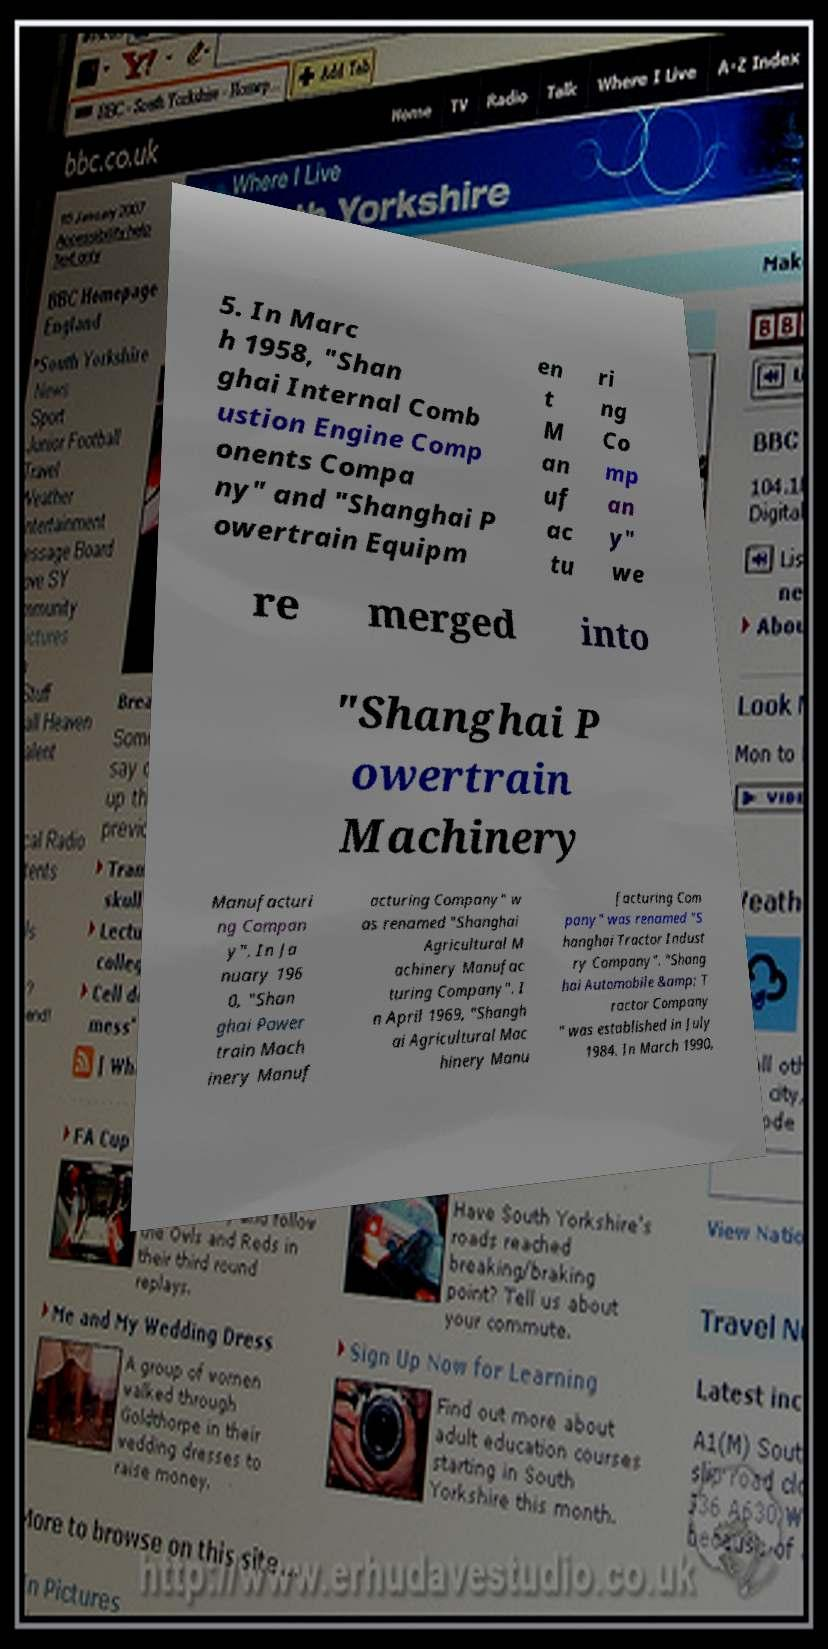For documentation purposes, I need the text within this image transcribed. Could you provide that? 5. In Marc h 1958, "Shan ghai Internal Comb ustion Engine Comp onents Compa ny" and "Shanghai P owertrain Equipm en t M an uf ac tu ri ng Co mp an y" we re merged into "Shanghai P owertrain Machinery Manufacturi ng Compan y". In Ja nuary 196 0, "Shan ghai Power train Mach inery Manuf acturing Company" w as renamed "Shanghai Agricultural M achinery Manufac turing Company". I n April 1969, "Shangh ai Agricultural Mac hinery Manu facturing Com pany" was renamed "S hanghai Tractor Indust ry Company". "Shang hai Automobile &amp; T ractor Company " was established in July 1984. In March 1990, 